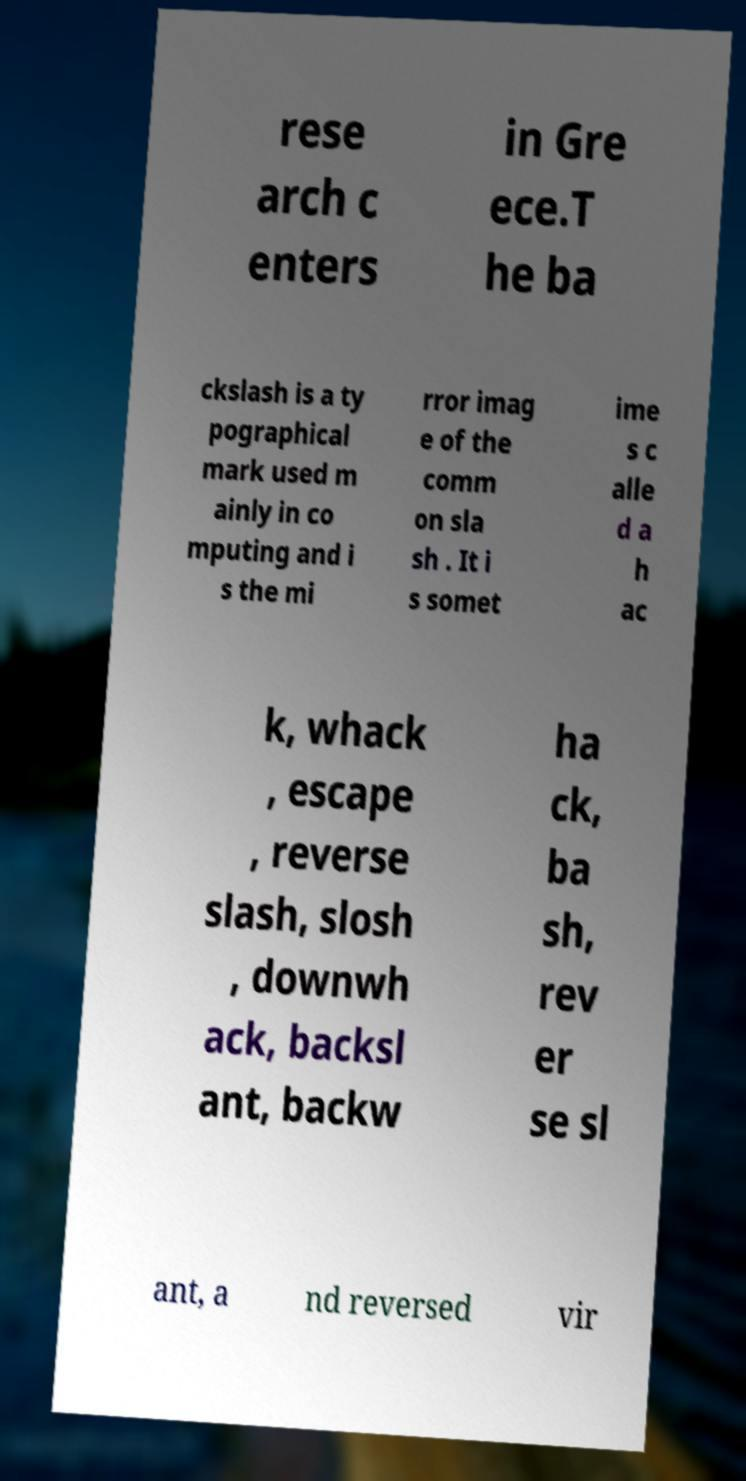Can you accurately transcribe the text from the provided image for me? rese arch c enters in Gre ece.T he ba ckslash is a ty pographical mark used m ainly in co mputing and i s the mi rror imag e of the comm on sla sh . It i s somet ime s c alle d a h ac k, whack , escape , reverse slash, slosh , downwh ack, backsl ant, backw ha ck, ba sh, rev er se sl ant, a nd reversed vir 